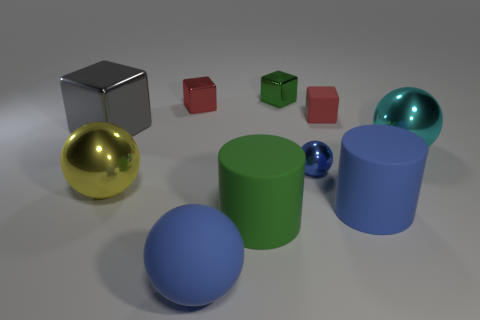Subtract all rubber spheres. How many spheres are left? 3 Subtract all cyan spheres. How many spheres are left? 3 Subtract 2 cylinders. How many cylinders are left? 0 Subtract all yellow cubes. How many blue spheres are left? 2 Subtract all big cyan objects. Subtract all red metallic objects. How many objects are left? 8 Add 6 blocks. How many blocks are left? 10 Add 5 small rubber blocks. How many small rubber blocks exist? 6 Subtract 0 yellow blocks. How many objects are left? 10 Subtract all cubes. How many objects are left? 6 Subtract all red cylinders. Subtract all purple spheres. How many cylinders are left? 2 